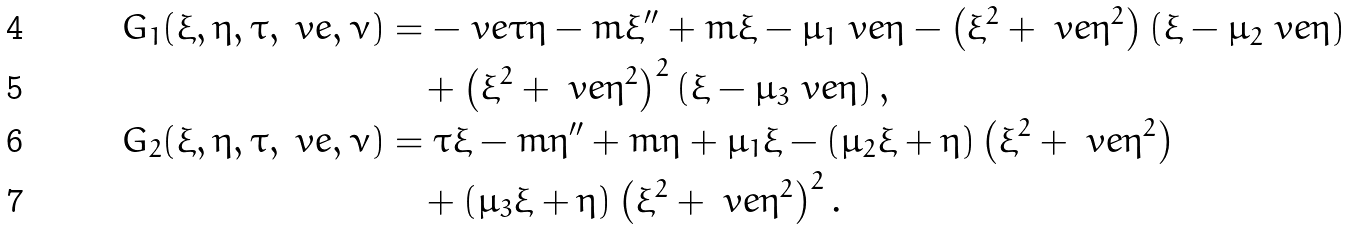Convert formula to latex. <formula><loc_0><loc_0><loc_500><loc_500>G _ { 1 } ( \xi , \eta , \tau , \ v e , \nu ) & = - \ v e \tau \eta - m \xi ^ { \prime \prime } + m \xi - \mu _ { 1 } \ v e \eta - \left ( \xi ^ { 2 } + \ v e \eta ^ { 2 } \right ) \left ( \xi - \mu _ { 2 } \ v e \eta \right ) \\ & \quad + \left ( \xi ^ { 2 } + \ v e \eta ^ { 2 } \right ) ^ { 2 } \left ( \xi - \mu _ { 3 } \ v e \eta \right ) , \\ G _ { 2 } ( \xi , \eta , \tau , \ v e , \nu ) & = \tau \xi - m \eta ^ { \prime \prime } + m \eta + \mu _ { 1 } \xi - \left ( \mu _ { 2 } \xi + \eta \right ) \left ( \xi ^ { 2 } + \ v e \eta ^ { 2 } \right ) \\ & \quad + \left ( \mu _ { 3 } \xi + \eta \right ) \left ( \xi ^ { 2 } + \ v e \eta ^ { 2 } \right ) ^ { 2 } .</formula> 